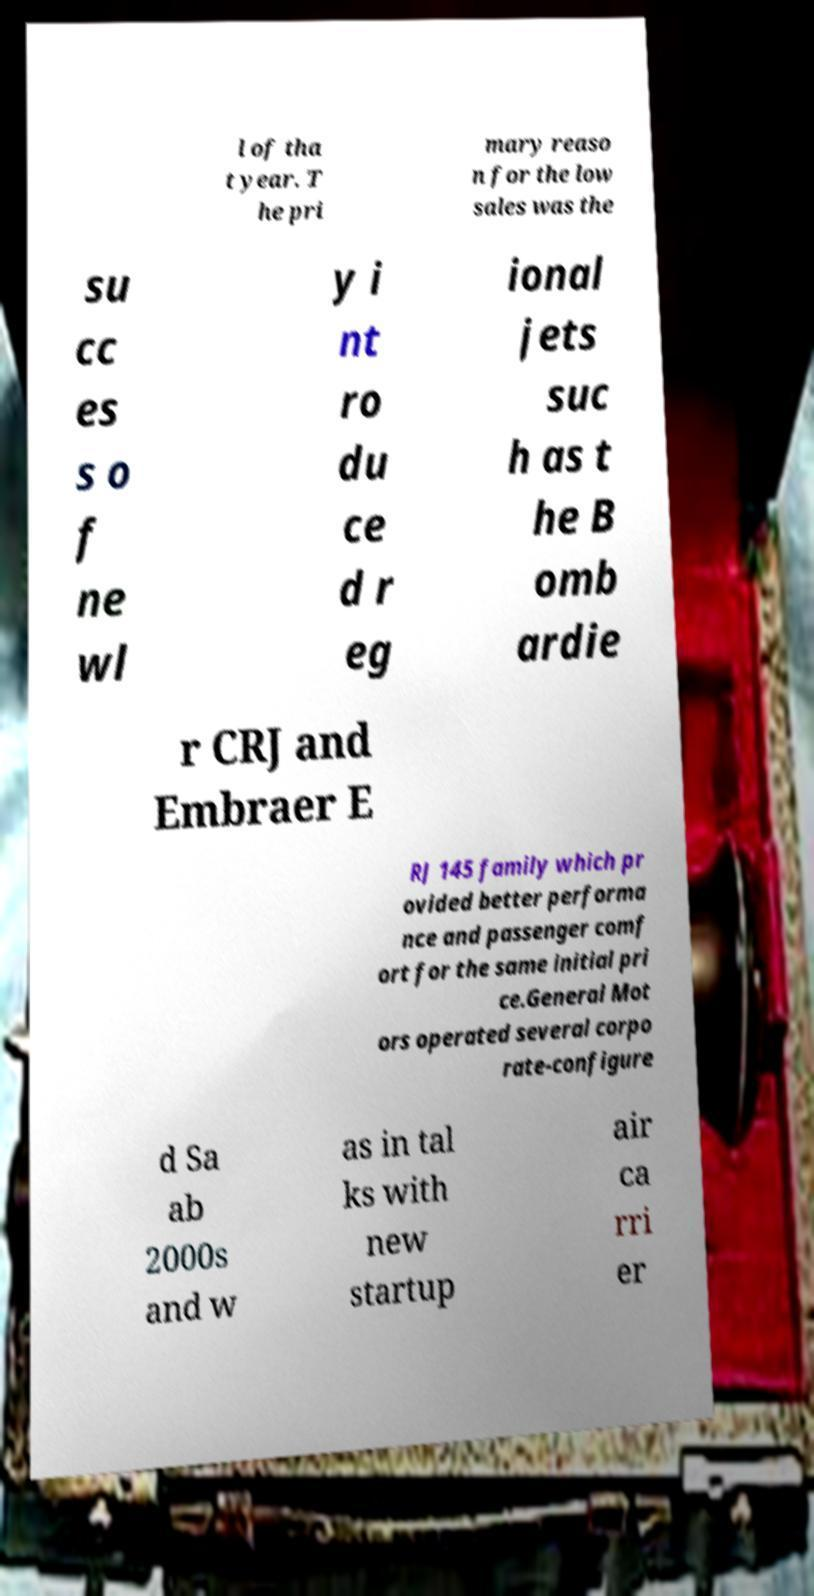Could you assist in decoding the text presented in this image and type it out clearly? l of tha t year. T he pri mary reaso n for the low sales was the su cc es s o f ne wl y i nt ro du ce d r eg ional jets suc h as t he B omb ardie r CRJ and Embraer E RJ 145 family which pr ovided better performa nce and passenger comf ort for the same initial pri ce.General Mot ors operated several corpo rate-configure d Sa ab 2000s and w as in tal ks with new startup air ca rri er 